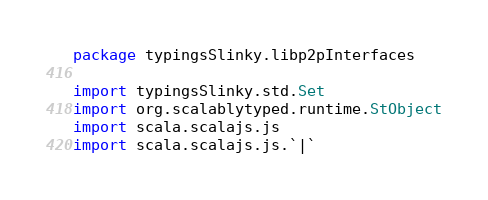<code> <loc_0><loc_0><loc_500><loc_500><_Scala_>package typingsSlinky.libp2pInterfaces

import typingsSlinky.std.Set
import org.scalablytyped.runtime.StObject
import scala.scalajs.js
import scala.scalajs.js.`|`</code> 